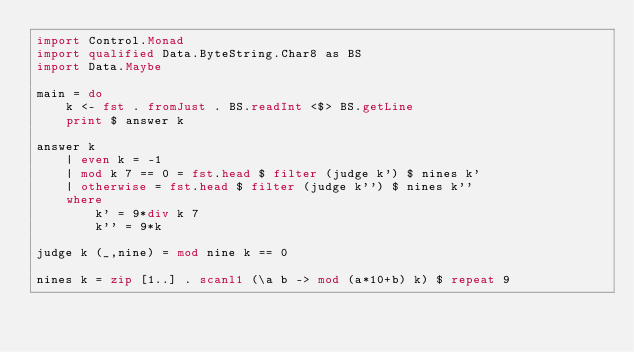Convert code to text. <code><loc_0><loc_0><loc_500><loc_500><_Haskell_>import Control.Monad
import qualified Data.ByteString.Char8 as BS
import Data.Maybe

main = do
    k <- fst . fromJust . BS.readInt <$> BS.getLine
    print $ answer k

answer k
    | even k = -1
    | mod k 7 == 0 = fst.head $ filter (judge k') $ nines k'
    | otherwise = fst.head $ filter (judge k'') $ nines k''
    where
        k' = 9*div k 7
        k'' = 9*k

judge k (_,nine) = mod nine k == 0

nines k = zip [1..] . scanl1 (\a b -> mod (a*10+b) k) $ repeat 9</code> 